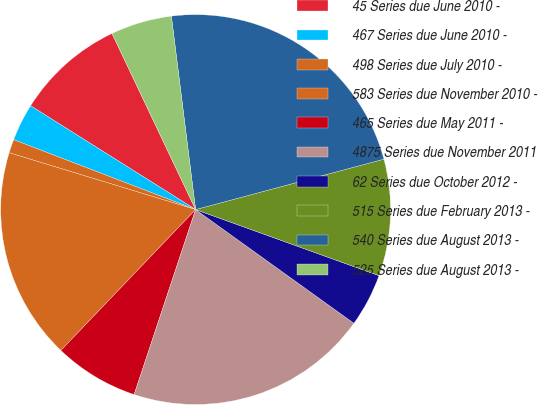Convert chart to OTSL. <chart><loc_0><loc_0><loc_500><loc_500><pie_chart><fcel>45 Series due June 2010 -<fcel>467 Series due June 2010 -<fcel>498 Series due July 2010 -<fcel>583 Series due November 2010 -<fcel>465 Series due May 2011 -<fcel>4875 Series due November 2011<fcel>62 Series due October 2012 -<fcel>515 Series due February 2013 -<fcel>540 Series due August 2013 -<fcel>525 Series due August 2013 -<nl><fcel>9.01%<fcel>3.1%<fcel>1.13%<fcel>17.56%<fcel>7.04%<fcel>20.19%<fcel>4.41%<fcel>9.67%<fcel>22.82%<fcel>5.07%<nl></chart> 